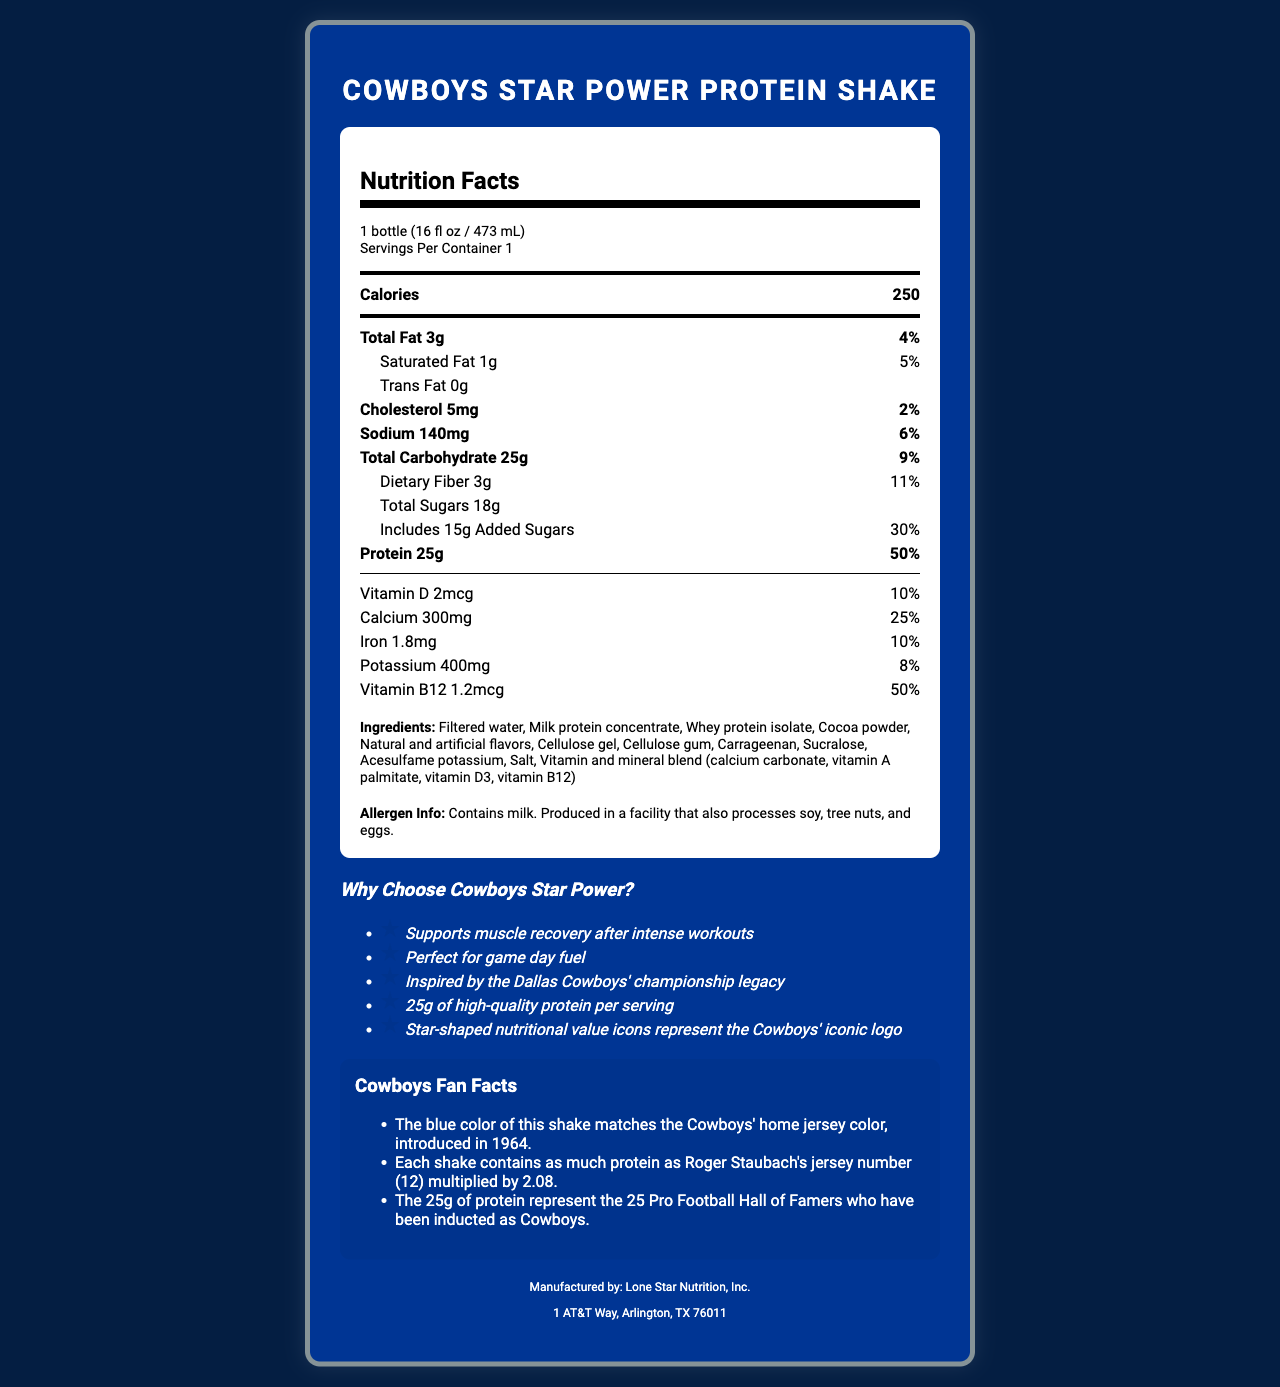what is the serving size of the Cowboys Star Power Protein Shake? The serving size is clearly stated in the serving info section of the nutrition facts.
Answer: 1 bottle (16 fl oz / 473 mL) how many calories are in one serving? The calorie count per serving is specified directly under the serving size information and emphasized in the nutrition facts section.
Answer: 250 what percentage of the daily value of protein does one serving provide? The protein information shows "25g" and "50%" next to it in the nutrient section.
Answer: 50% how much sodium is in one serving, and what is its daily value percentage? The sodium content, along with its daily value percentage, is listed in the nutrient section.
Answer: 140mg, 6% what are the marketing claims highlighted for the Cowboys Star Power Protein Shake? These points are explicitly stated in the "Why Choose Cowboys Star Power?" marketing claims section.
Answer: Supports muscle recovery after intense workouts, Perfect for game day fuel, Inspired by the Dallas Cowboys' championship legacy, 25g of high-quality protein per serving, Star-shaped nutritional value icons represent the Cowboys' iconic logo how much dietary fiber does the shake contain? The dietary fiber content is listed in the nutrient section under total carbohydrate.
Answer: 3g what vitamins and minerals are included in the additional blend of the shake? A. Vitamin C and Iron B. Vitamin A and Calcium C. Calcium Carbonate and Vitamin B12 D. Iron and Potassium The ingredient list shows that the vitamin and mineral blend includes calcium carbonate and vitamin B12, among others.
Answer: C what is the total amount of sugars in the shake, and how much of it is added sugars? A. 10g of total sugar, 8g of added sugars B. 18g of total sugar, 15g of added sugars C. 15g of total sugar, 5g of added sugars The nutrient section shows that there's a total of 18g of sugars with 15g being added sugars.
Answer: B does the Cowboys Star Power Protein Shake contain any allergens? The allergen info section states that it contains milk and is produced in a facility that processes soy, tree nuts, and eggs.
Answer: Yes summarize the main appeal of the Cowboys Star Power Protein Shake described in the document. This summary covers the overall theme and key features of the shake, including its nutritional benefits, marketing appeal, and unique design elements tied to the Dallas Cowboys.
Answer: The Cowboys Star Power Protein Shake is marketed as a high-protein drink perfect for muscle recovery and game day fuel, inspired by the Dallas Cowboys' legacy. It includes fun facts and star-shaped nutritional icons representing the team. The shake contains essential nutrients, supports muscle recovery, and has a high protein content, along with added vitamins and minerals. which company manufactures the Cowboys Star Power Protein Shake, and where is it located? The manufacturer and address are listed at the end of the document.
Answer: Lone Star Nutrition, Inc., 1 AT&T Way, Arlington, TX 76011 is the protein content in the shake equal to Roger Staubach's jersey number multiplied by 2.08? One of the fun facts confirms that the shake's 25g protein content equals Roger Staubach's jersey number (12) multiplied by 2.08.
Answer: Yes what is the blue color of the shake inspired by? This information is given in the fun facts section, linking the shake's color to the team's historic jersey color.
Answer: The Cowboys' home jersey color introduced in 1964 what other allergens might be present due to the manufacturing facility? The allergen info section indicates that the shake is made in a facility that processes these allergens.
Answer: Soy, tree nuts, and eggs how much saturated fat is in the shake? The nutrient section provides the amount of saturated fat and its daily value percentage.
Answer: 1g how many Pro Football Hall of Famers are represented by the protein content in the shake? The fun facts mention that the 25g of protein represent the 25 Hall of Famers inducted as Cowboys.
Answer: 25 can you determine if the shake is safe for someone with a soy allergy based on this document? The document states that the shake is produced in a facility that processes soy, but it does not provide information on the possibility of cross-contamination or specific safety for someone with a soy allergy.
Answer: Cannot be determined 